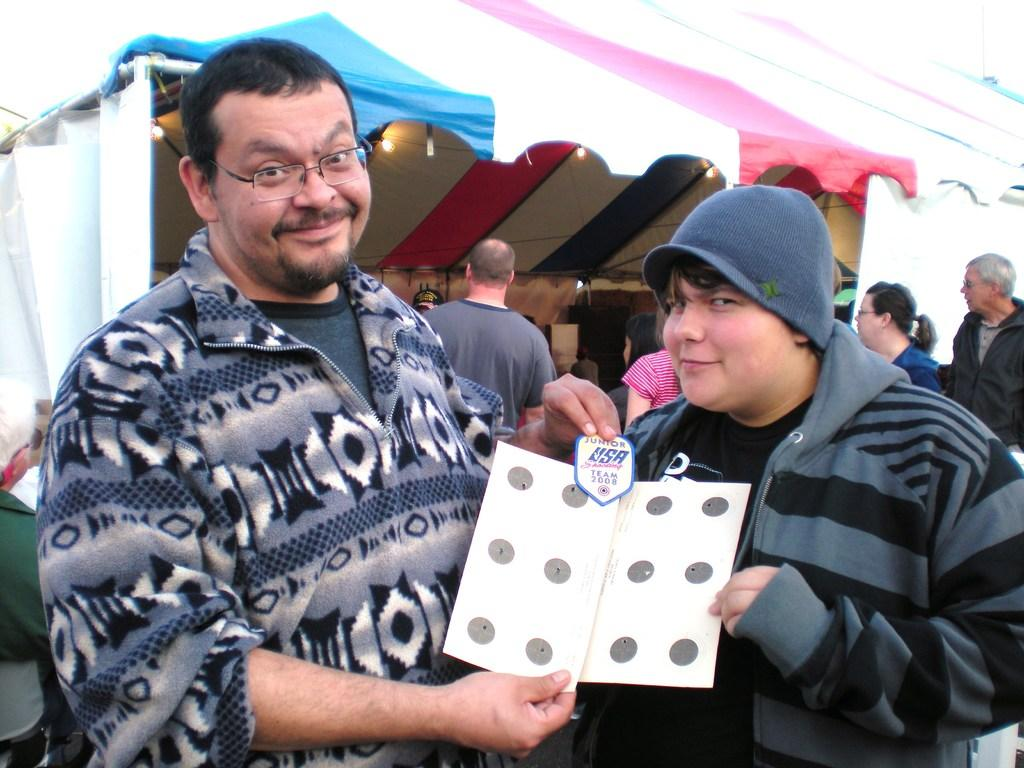What is happening in the center of the image? There are people in the center of the image. What are the people in the center holding? The people are holding a paper in their hands. Can you describe the background of the image? There are other people in the background, as well as a stall and lamps. What type of seed is being sold at the dock in the image? There is no dock or seed present in the image. What kind of food is being served at the stall in the image? The image does not show any food being served at the stall; it only shows a stall in the background. 